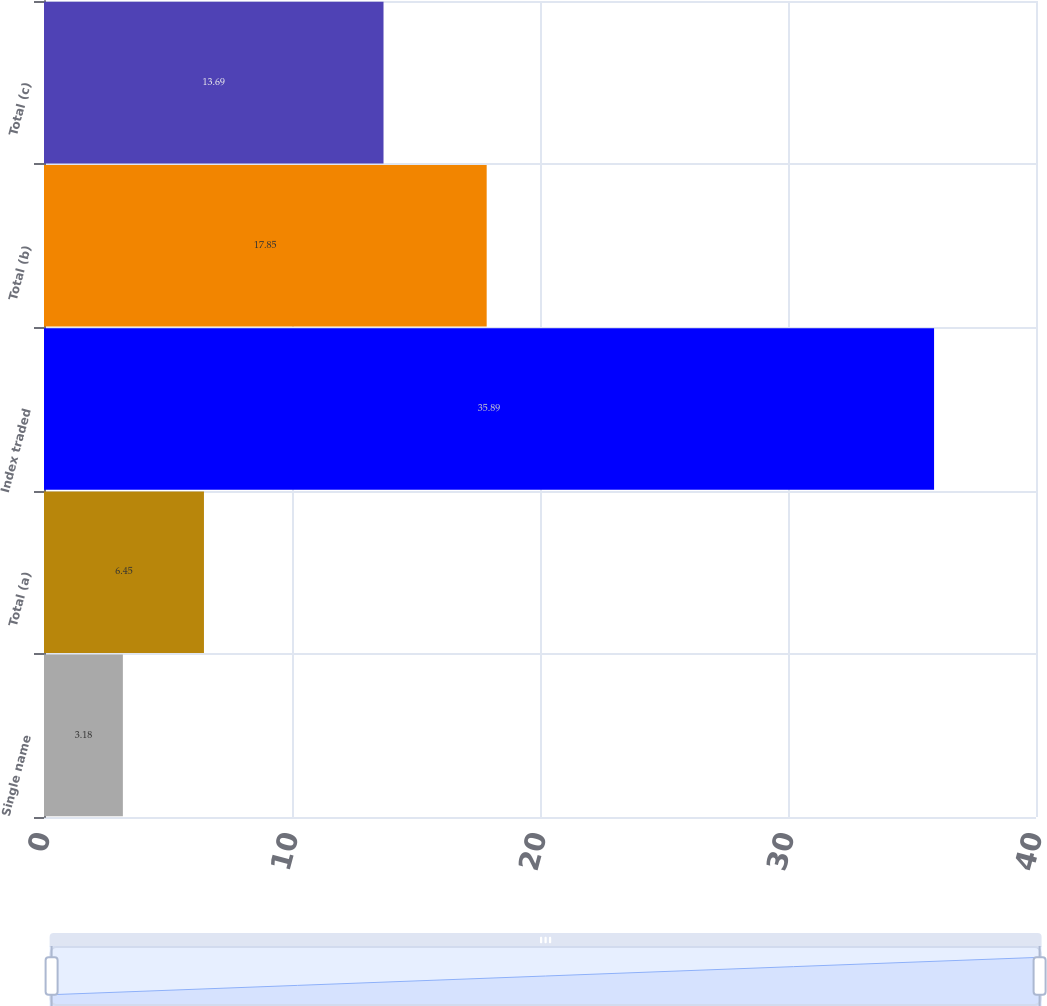<chart> <loc_0><loc_0><loc_500><loc_500><bar_chart><fcel>Single name<fcel>Total (a)<fcel>Index traded<fcel>Total (b)<fcel>Total (c)<nl><fcel>3.18<fcel>6.45<fcel>35.89<fcel>17.85<fcel>13.69<nl></chart> 